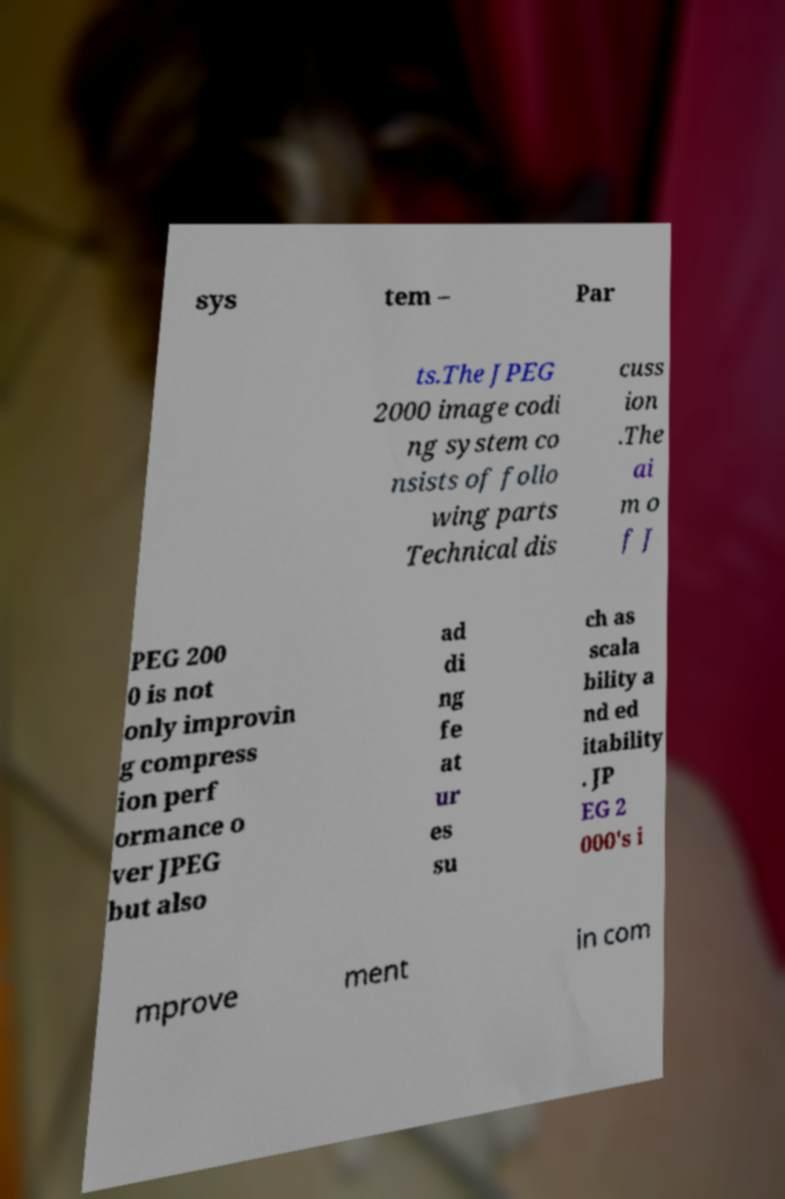Can you accurately transcribe the text from the provided image for me? sys tem – Par ts.The JPEG 2000 image codi ng system co nsists of follo wing parts Technical dis cuss ion .The ai m o f J PEG 200 0 is not only improvin g compress ion perf ormance o ver JPEG but also ad di ng fe at ur es su ch as scala bility a nd ed itability . JP EG 2 000's i mprove ment in com 